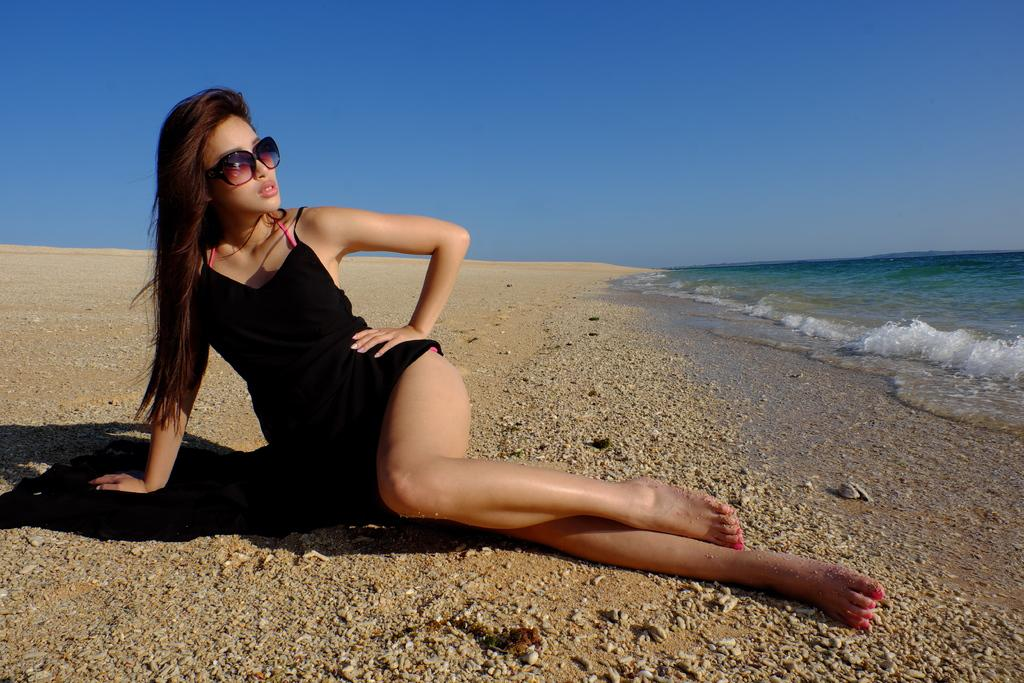What type of natural environment is depicted in the image? The image features a sky, sea, and beach. What type of land meets the sea in the image? There is a beach in the image where the land meets the sea. Are there any people present in the image? Yes, there is a lady in the image. How many legs does the car have in the image? There is no car present in the image, so it is not possible to determine the number of legs it might have. 